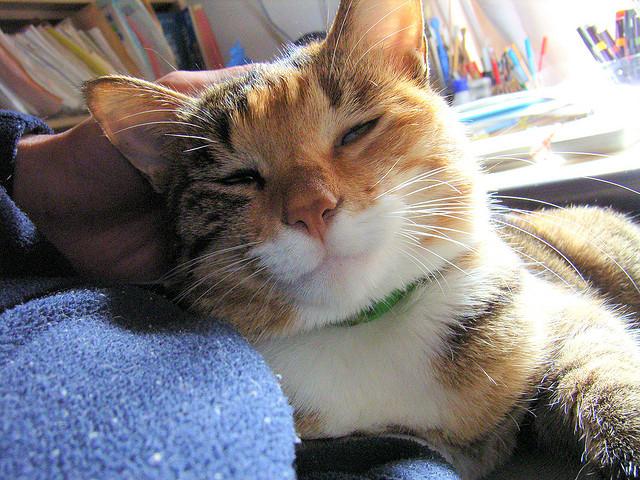Is the cat scared?
Concise answer only. No. Is the cat relaxed?
Short answer required. Yes. What is the color of the cat's collar?
Quick response, please. Green. 